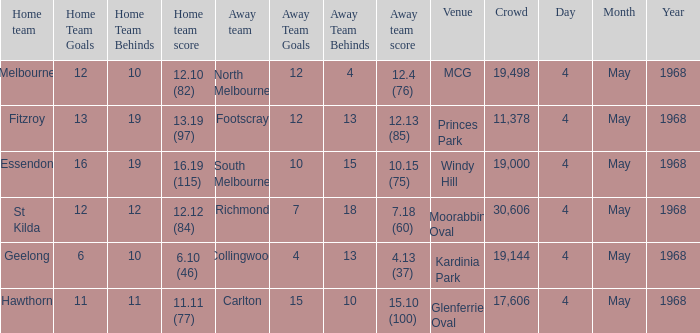What home team played at MCG? North Melbourne. 